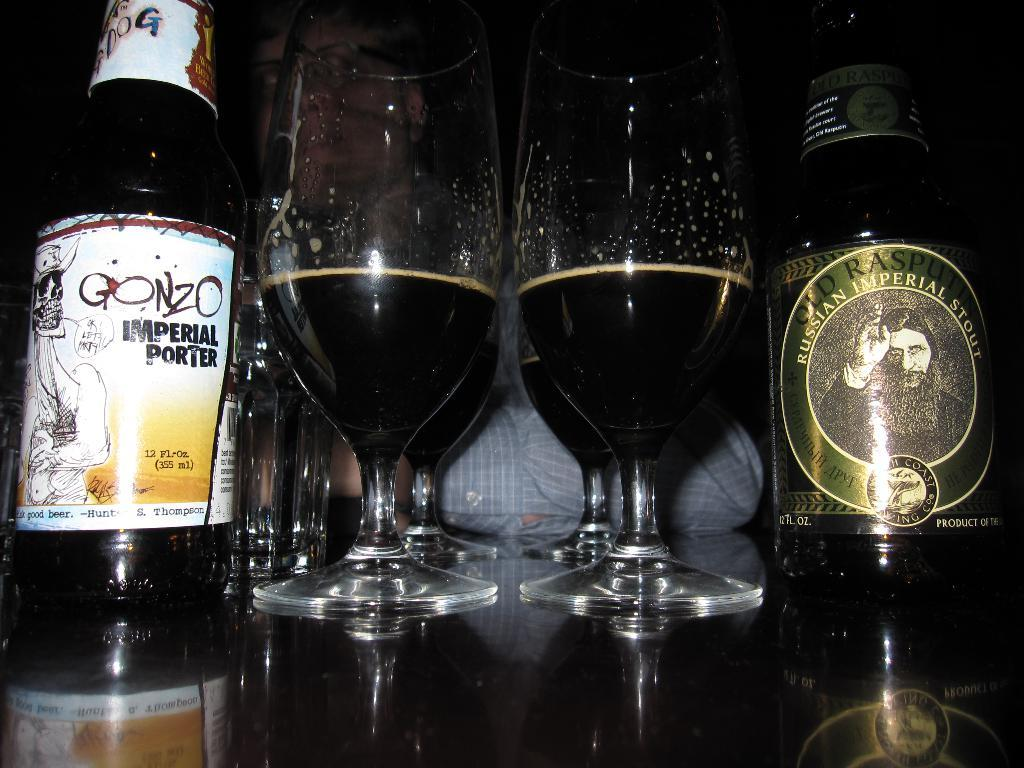What type of glasses are visible in the image? There are wine glasses with liquid in the image. What else can be seen on the surface in the image? There are bottles on the surface in the image. Can you describe the person in the background of the image? A person wearing glasses is visible in the background of the image. What type of writing can be seen on the wine glasses in the image? There is no writing visible on the wine glasses in the image. 